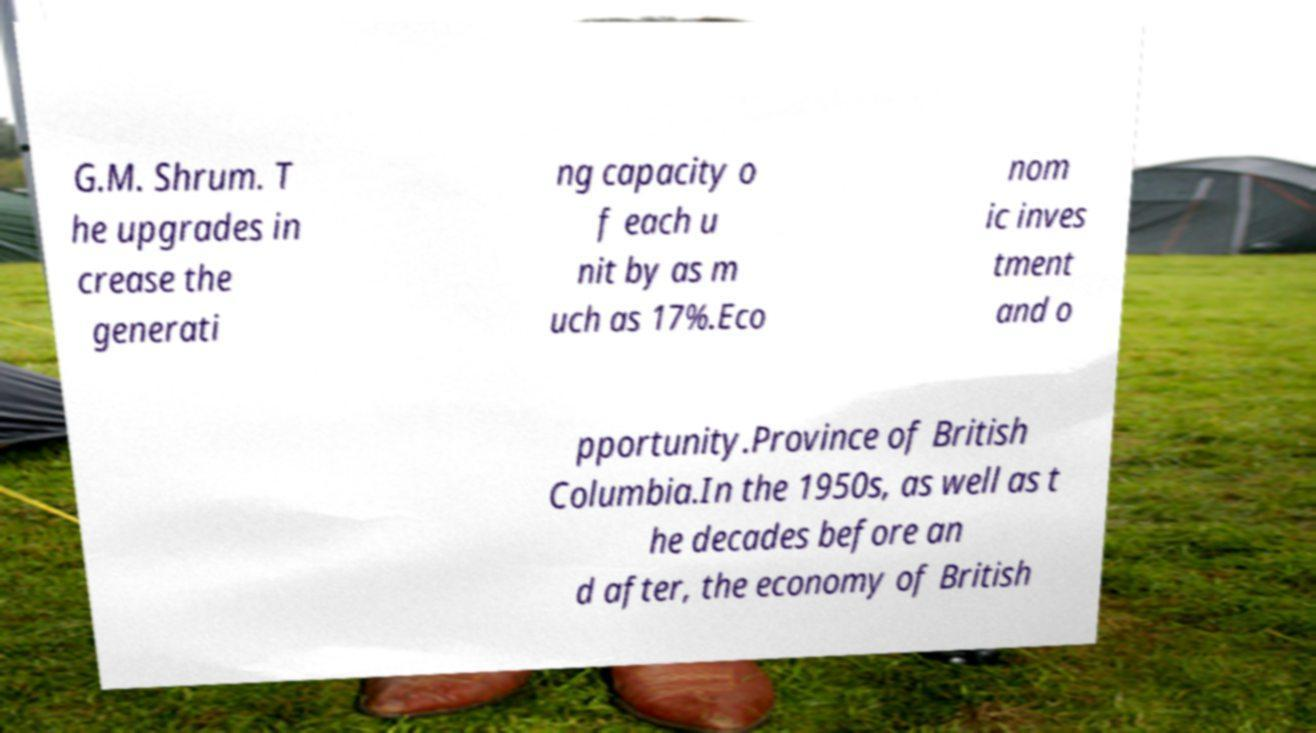Please read and relay the text visible in this image. What does it say? G.M. Shrum. T he upgrades in crease the generati ng capacity o f each u nit by as m uch as 17%.Eco nom ic inves tment and o pportunity.Province of British Columbia.In the 1950s, as well as t he decades before an d after, the economy of British 